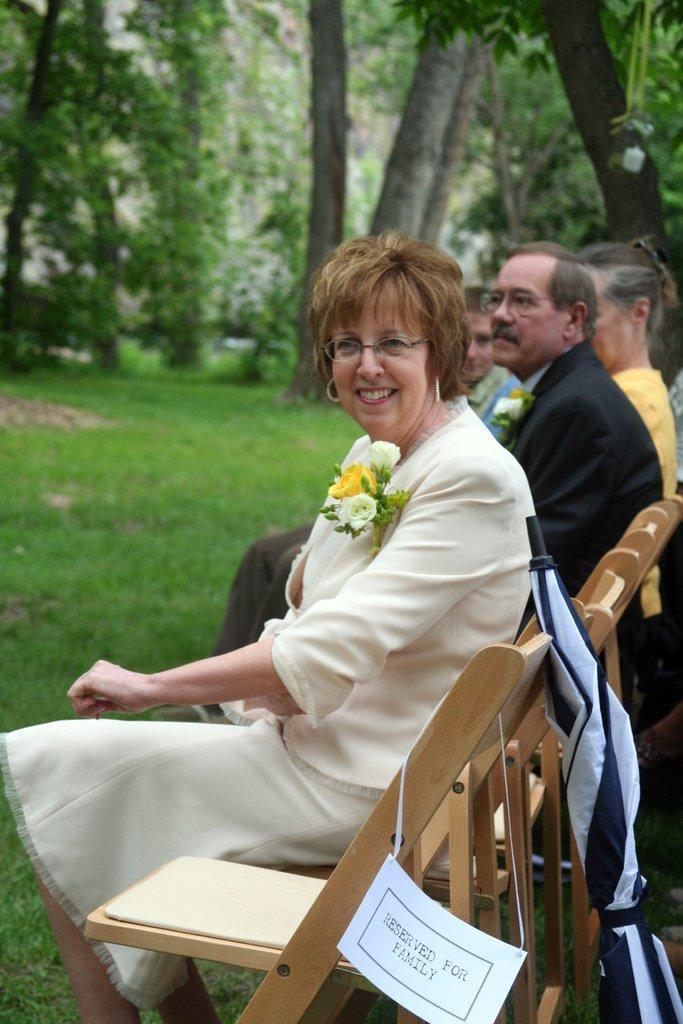Could you give a brief overview of what you see in this image? On the background we can see trees. This is a fresh green grass. Here we can see few persons sitting on chairs. This is an umbrella in black and white colour. Here we can see a board which is hanged to the chair. 